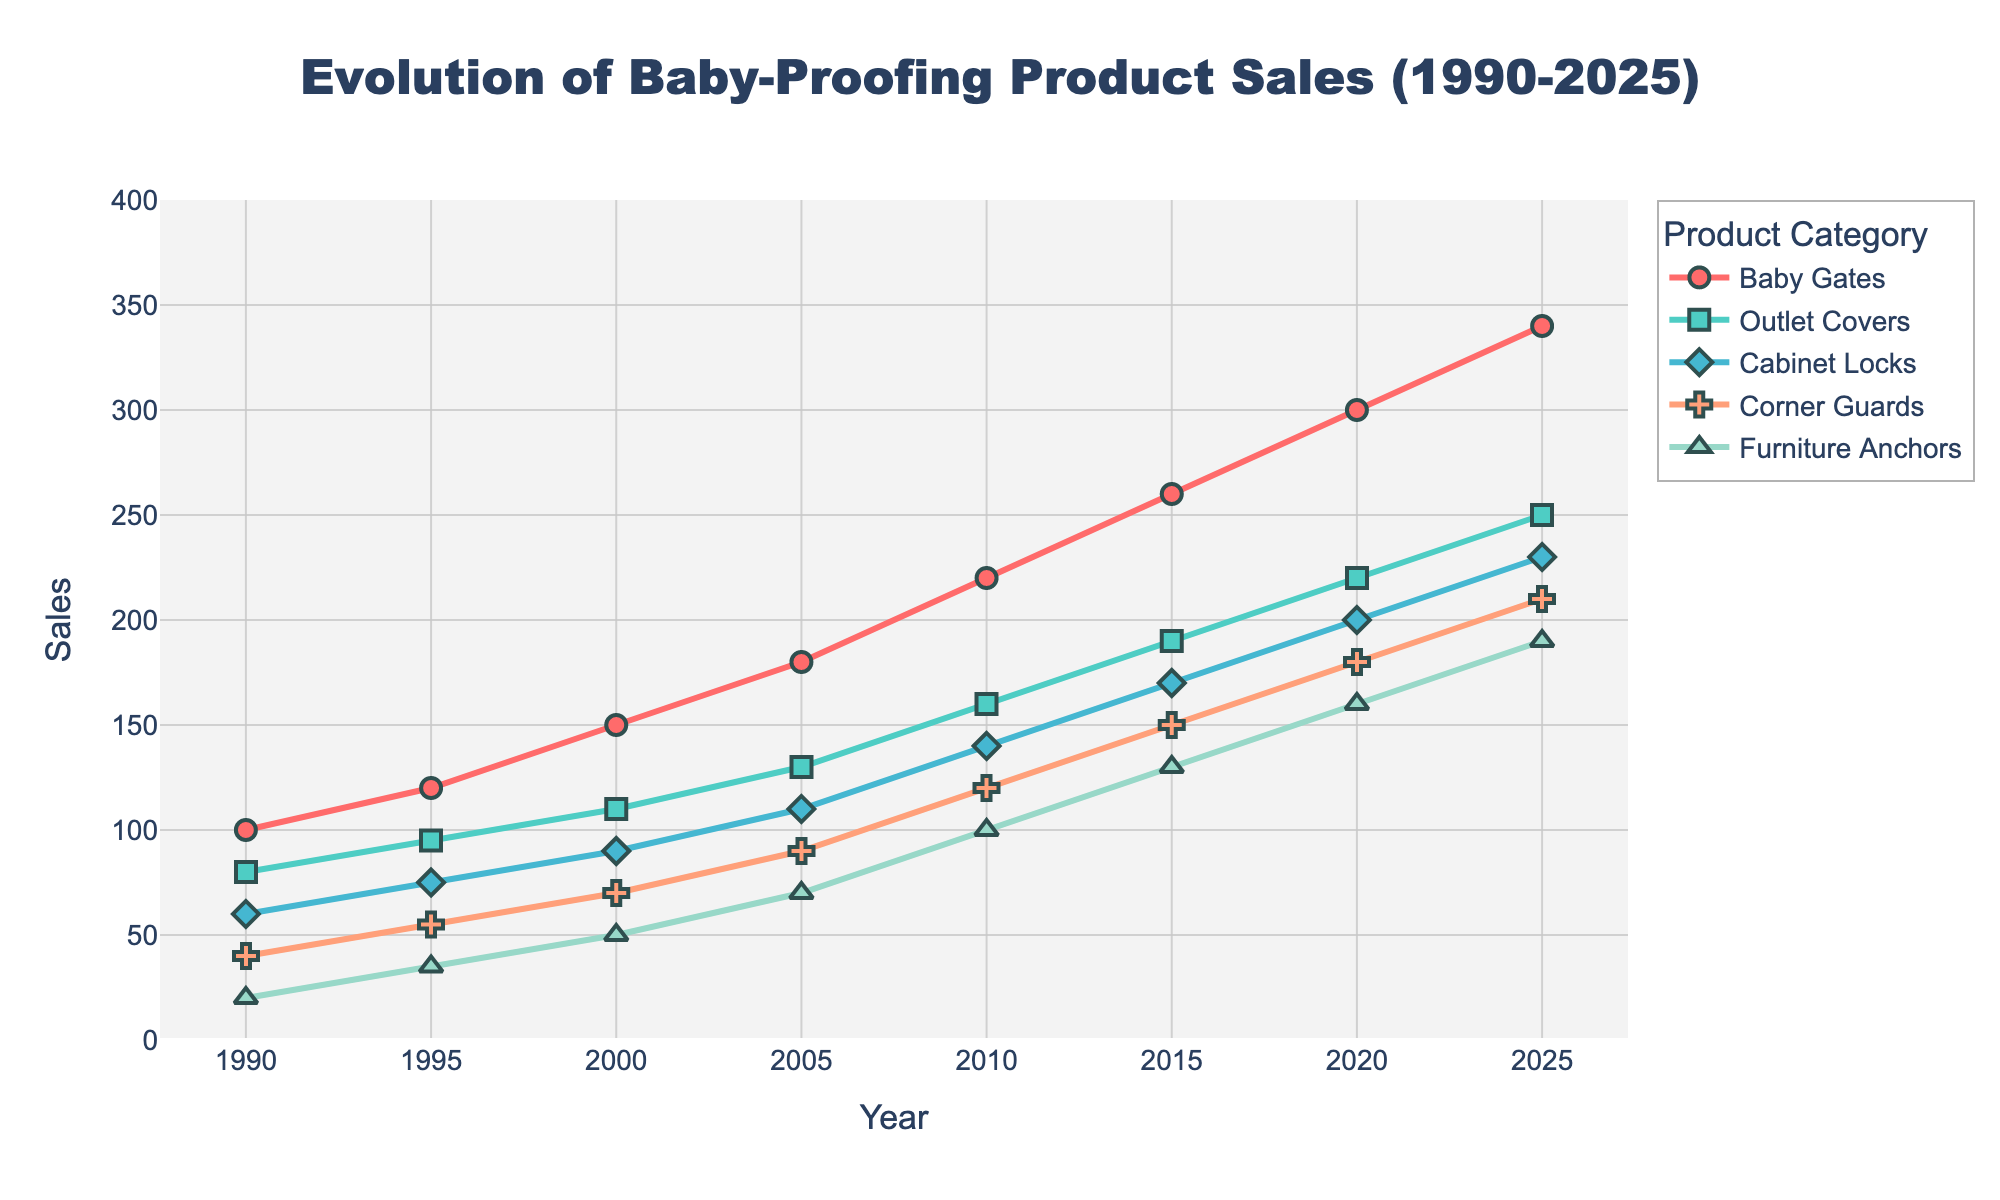What year did sales of Baby Gates first exceed 200 units? Look for the year where the "Baby Gates" sales cross 200 units on the line plot. It happens around 2010.
Answer: 2010 Which product category had the highest sales in the year 2000? Examine the data points for each product category in the year 2000. Baby Gates had the highest sales at 150 units.
Answer: Baby Gates Between which two years did Furniture Anchors see the largest increase in sales? Compare the sales of Furniture Anchors between consecutive years. The largest increase happened between 2010 (100) and 2015 (130), which is a 30-unit increase.
Answer: 2010 and 2015 How many total sales did Cabinet Locks have from 1990 to 2025? Sum the sales of Cabinet Locks from all the years provided: 60 + 75 + 90 + 110 + 140 + 170 + 200 + 230 = 1075.
Answer: 1075 What is the difference in the sales of Outlet Covers between 2005 and 2025? Subtract the sales of Outlet Covers in 2005 from their sales in 2025: 250 - 130 = 120.
Answer: 120 Which product saw the least growth in sales from 1990 to 2025? Calculate the difference in sales from 1990 to 2025 for each product. Corner Guards went from 40 to 210, an increase of 170. Other products had larger increases: Baby Gates (240), Outlet Covers (170), Cabinet Locks (170), Furniture Anchors (170). Since several products have equal growth, let's break down one more pair to ensure there's no smaller growth. So, we expand further: Baby Gates (240 units increase), Outlet Covers (170), Cabinet Locks (170), Corner Guards (170), Furniture Anchors (170). All equal rises except Baby Gates are lower. So, Corner Guards are least significant among equal rises.
Answer: Corner Guards In which year did Cabinet Locks and Corner Guards have equal sales? Find the intersection of the sales data for Cabinet Locks and Corner Guards. Both had sales of 110 units in 2005.
Answer: 2005 What average sales value did Furniture Anchors have across all measured years? Calculate the average by summing Furniture Anchor sales and dividing by the number of data points (8): (20 + 35 + 50 + 70 + 100 + 130 + 160 + 190) / 8 = 93.125.
Answer: 93.125 Which product category had consistent growth every five years from 1990 to 2025? Verify if the sales data points show increasing sales every five years. Baby Gates consistently increase in each period: 100, 120, 150, 180, 220, 260, 300, 340.
Answer: Baby Gates 